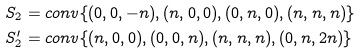Convert formula to latex. <formula><loc_0><loc_0><loc_500><loc_500>S _ { 2 } & = c o n v \{ ( 0 , 0 , - n ) , ( n , 0 , 0 ) , ( 0 , n , 0 ) , ( n , n , n ) \} \\ S ^ { \prime } _ { 2 } & = c o n v \{ ( n , 0 , 0 ) , ( 0 , 0 , n ) , ( n , n , n ) , ( 0 , n , 2 n ) \}</formula> 